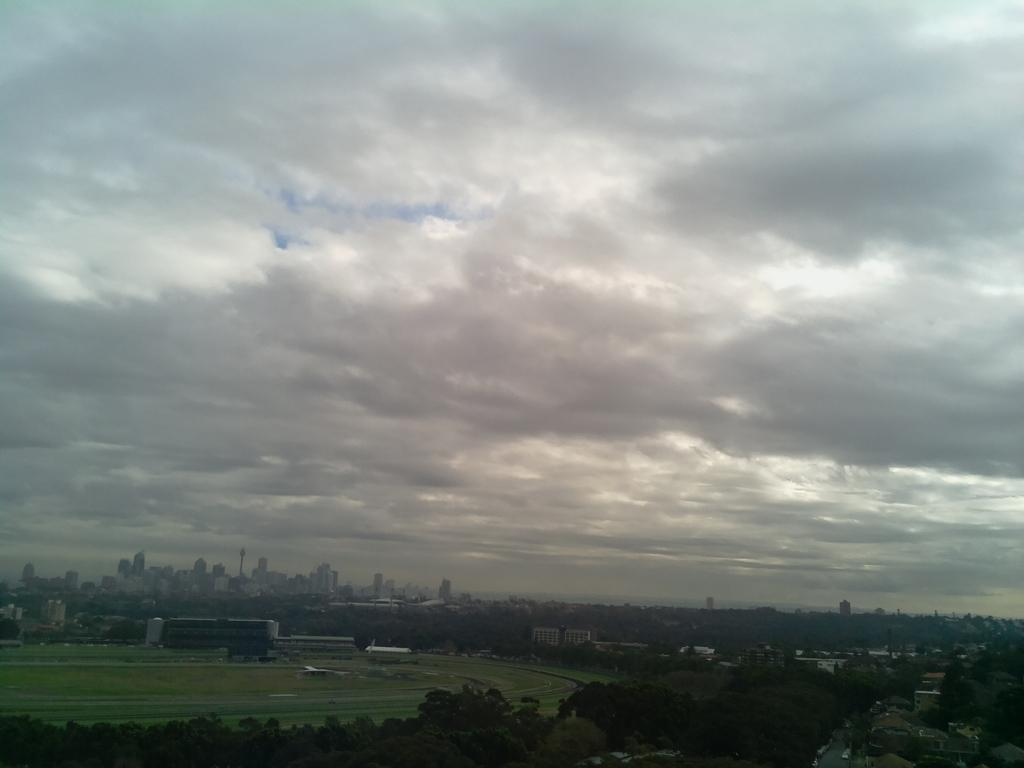What type of structures can be seen in the image? There are buildings in the image. What other natural elements are present in the image? There are trees in the image. What part of the natural environment is visible in the image? The sky is visible in the image. What can be observed in the sky? Clouds are present in the image. How would you describe the overall lighting in the image? The image appears to be slightly dark. How many cows are grazing in the field in the image? There are no cows or fields present in the image; it features buildings, trees, and a sky with clouds. 